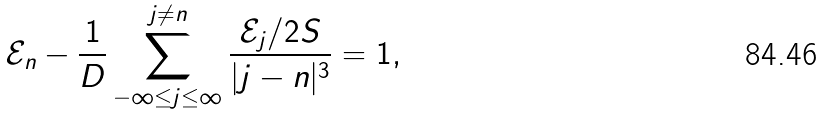Convert formula to latex. <formula><loc_0><loc_0><loc_500><loc_500>\mathcal { E } _ { n } - \frac { 1 } { D } \sum _ { - \infty \leq j \leq \infty } ^ { j \ne n } \frac { \mathcal { E } _ { j } / 2 S } { | j - n | ^ { 3 } } = 1 ,</formula> 